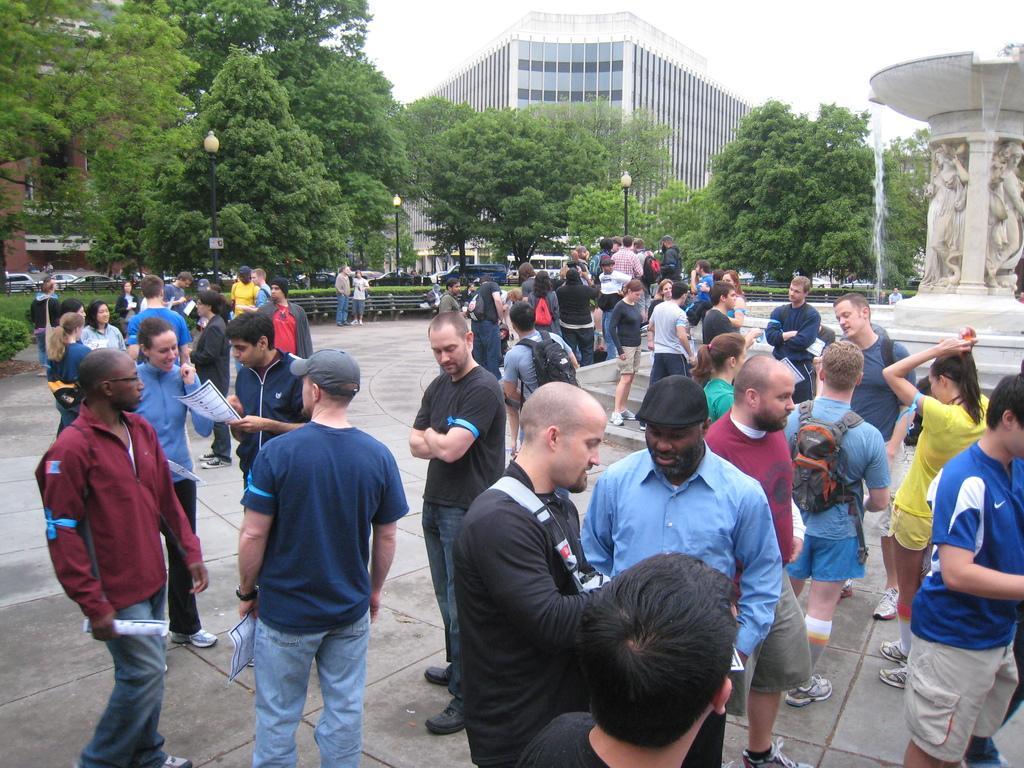In one or two sentences, can you explain what this image depicts? This is an outside view. Here I can see a crowd of people standing on the ground. On the right side there is a fountain. On the left side there are many vehicles and poles. In the background there are many trees and a building. At the top of the image I can see the sky. 